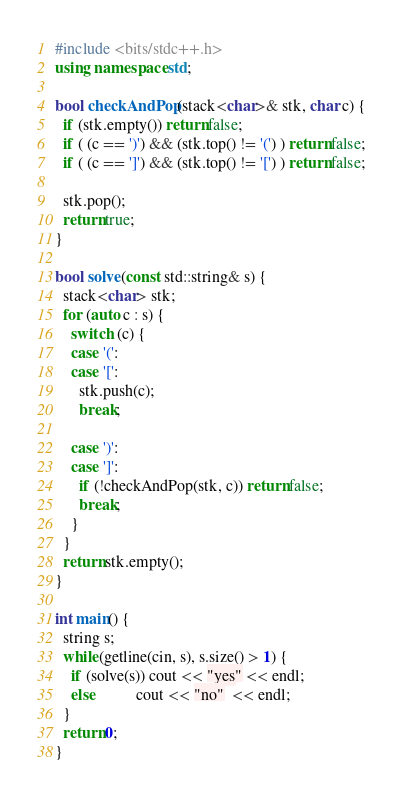<code> <loc_0><loc_0><loc_500><loc_500><_C++_>#include <bits/stdc++.h>
using namespace std;

bool checkAndPop(stack<char>& stk, char c) {
  if (stk.empty()) return false; 
  if ( (c == ')') && (stk.top() != '(') ) return false;
  if ( (c == ']') && (stk.top() != '[') ) return false;

  stk.pop();
  return true;
}

bool solve(const std::string& s) {
  stack<char> stk;
  for (auto c : s) {
    switch (c) {
    case '(':
    case '[':
      stk.push(c);
      break;
      
    case ')':
    case ']':
      if (!checkAndPop(stk, c)) return false;
      break;
    }
  }
  return stk.empty();
}

int main() {
  string s;
  while(getline(cin, s), s.size() > 1) {
    if (solve(s)) cout << "yes" << endl;
    else          cout << "no"  << endl;
  }
  return 0;
}
</code> 